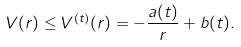<formula> <loc_0><loc_0><loc_500><loc_500>V ( r ) \leq V ^ { ( t ) } ( r ) = - \frac { a ( t ) } { r } + b ( t ) .</formula> 